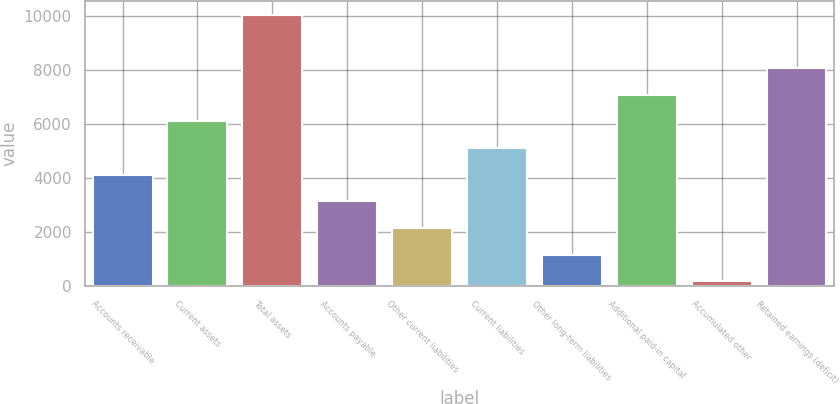Convert chart. <chart><loc_0><loc_0><loc_500><loc_500><bar_chart><fcel>Accounts receivable<fcel>Current assets<fcel>Total assets<fcel>Accounts payable<fcel>Other current liabilities<fcel>Current liabilities<fcel>Other long-term liabilities<fcel>Additional paid-in capital<fcel>Accumulated other<fcel>Retained earnings (deficit)<nl><fcel>4129<fcel>6107<fcel>10063<fcel>3140<fcel>2151<fcel>5118<fcel>1162<fcel>7096<fcel>173<fcel>8085<nl></chart> 